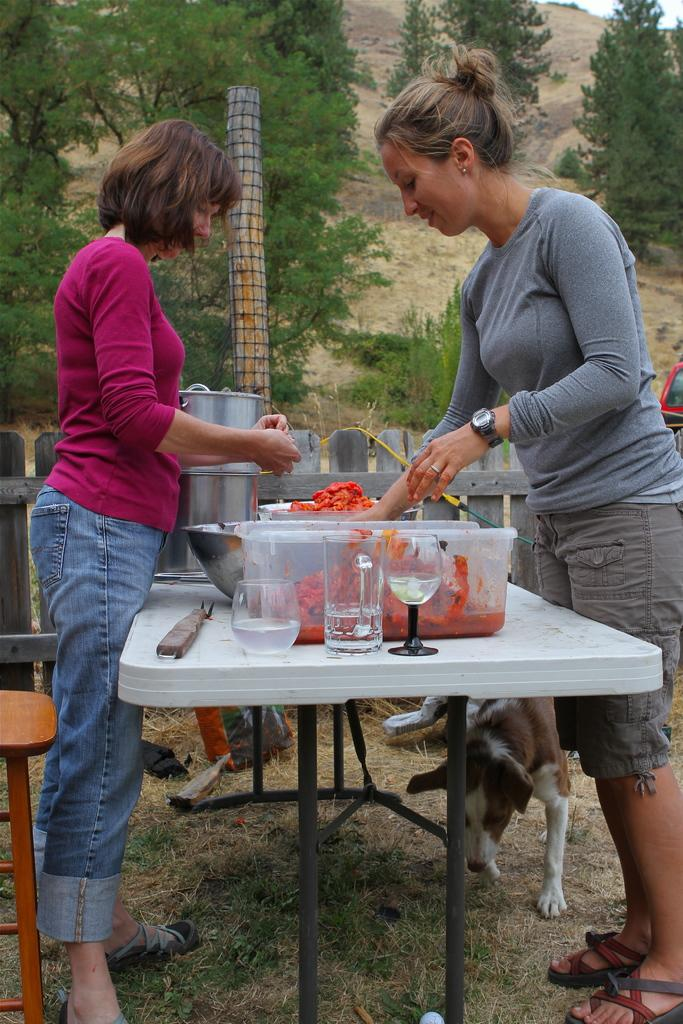How many women are present in the image? There are two women in the image. What are the women doing in the image? The women are standing around a table. What objects can be seen on the table? There are glasses and a container on the table. What is visible in the background of the image? There is a dog and trees in the background of the image. What type of waves can be seen crashing against the shore in the image? There are no waves or shore visible in the image; it features two women standing around a table with glasses and a container. Can you tell me how many squirrels are climbing the trees in the background? There are no squirrels visible in the image; only a dog and trees can be seen in the background. 